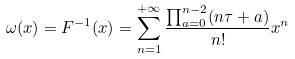Convert formula to latex. <formula><loc_0><loc_0><loc_500><loc_500>\omega ( x ) = F ^ { - 1 } ( x ) = \sum _ { n = 1 } ^ { + \infty } \frac { \prod _ { a = 0 } ^ { n - 2 } ( n \tau + a ) } { n ! } x ^ { n }</formula> 